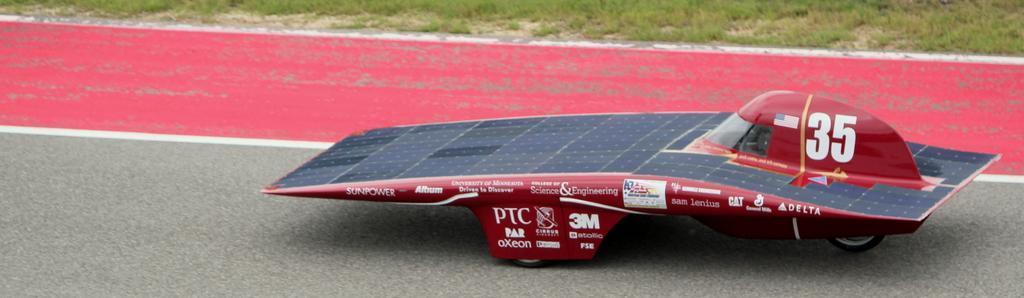Could you give a brief overview of what you see in this image? In this image in the center there is one vehicle, and in the background there is grass and at the bottom there is a road. 